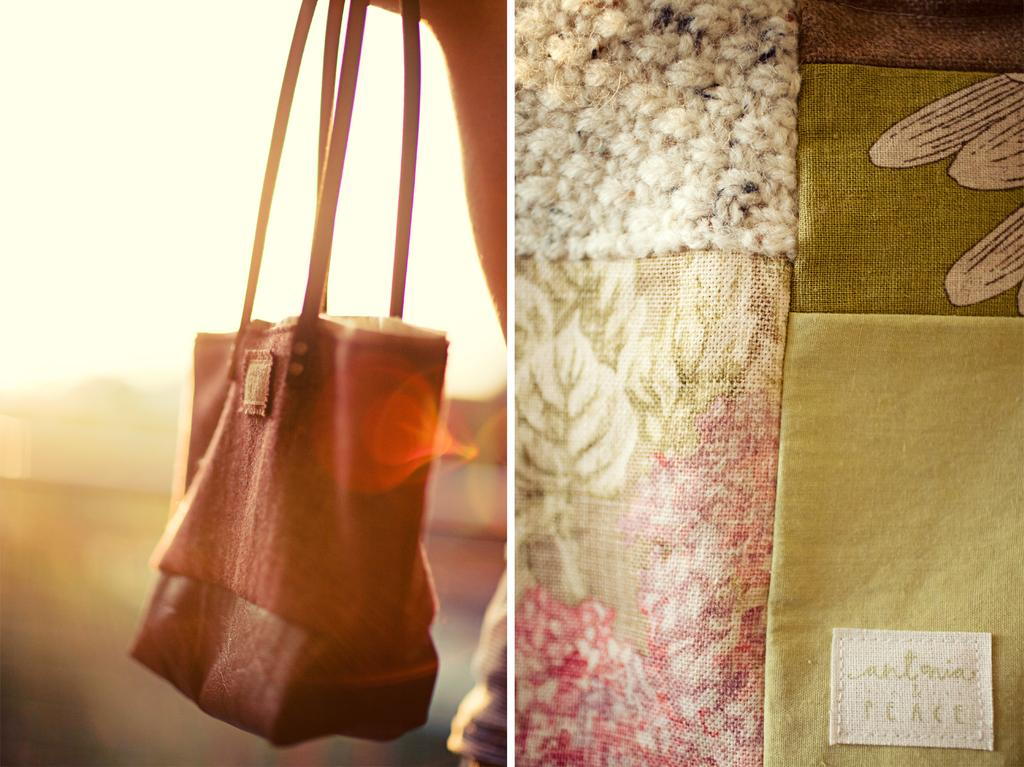Who or what is present in the image? There is a person in the image. What is the person holding? The person is holding a bag. What color is the bag? The bag is red. What can be seen on the right side of the image? There is a cloth on the right side of the image. What is visible in the background of the image? Mountains are visible in the background. What is visible at the top of the image? The sky is visible at the top of the image. How many girls are shown expressing disgust towards mint in the image? There are no girls or mint present in the image. 